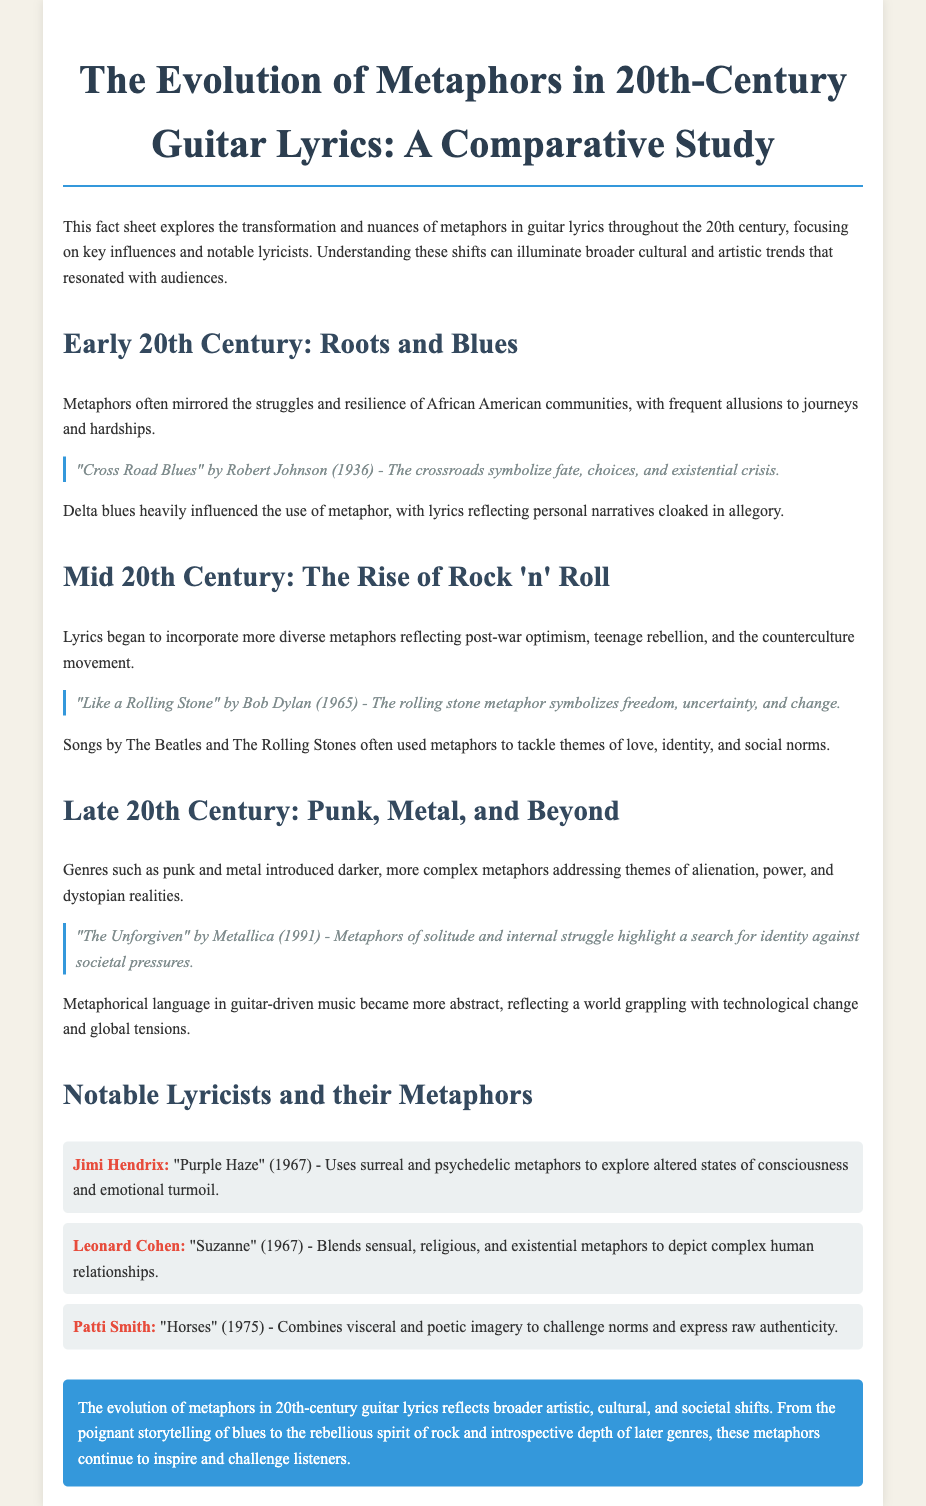What is the focus of the fact sheet? The focus of the fact sheet is on the transformation and nuances of metaphors in guitar lyrics throughout the 20th century.
Answer: Transformation and nuances of metaphors in guitar lyrics Who wrote "Cross Road Blues"? "Cross Road Blues" is attributed to Robert Johnson, a key figure in blues music.
Answer: Robert Johnson In what year was "Like a Rolling Stone" released? "Like a Rolling Stone" was released in 1965, marking a significant moment in rock lyrics.
Answer: 1965 Which genre introduced darker themes and complex metaphors in the late 20th century? Punk and metal genres introduced darker and more complex metaphors during this period.
Answer: Punk and metal What does the metaphor "rolling stone" symbolize according to Bob Dylan? The metaphor "rolling stone" symbolizes freedom, uncertainty, and change in Dylan's lyrics.
Answer: Freedom, uncertainty, and change How did metaphors in early 20th-century guitar lyrics reflect cultural contexts? Metaphors often mirrored the struggles and resilience of African American communities, indicating socio-cultural conditions.
Answer: Struggles and resilience of African American communities What is a notable theme in Patti Smith's "Horses"? A notable theme in "Horses" is challenging norms and expressing raw authenticity through visceral imagery.
Answer: Challenging norms and expressing raw authenticity What significant lyrical shift occurred in the mid-20th century? Lyrics began to incorporate more diverse metaphors reflecting post-war optimism and teenage rebellion during this time.
Answer: Post-war optimism and teenage rebellion Who is known for using surreal and psychedelic metaphors in their lyrics? Jimi Hendrix is known for using surreal and psychedelic metaphors in songs like "Purple Haze."
Answer: Jimi Hendrix 